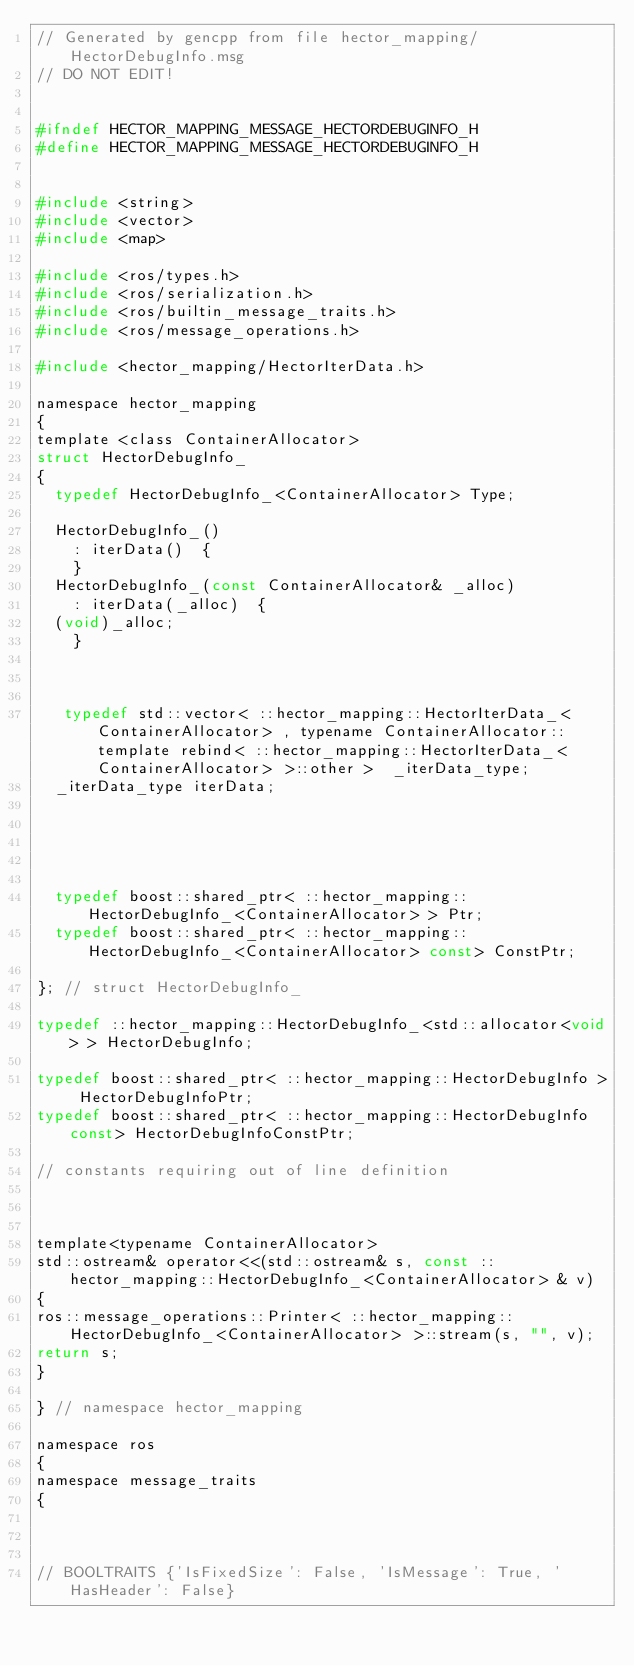<code> <loc_0><loc_0><loc_500><loc_500><_C_>// Generated by gencpp from file hector_mapping/HectorDebugInfo.msg
// DO NOT EDIT!


#ifndef HECTOR_MAPPING_MESSAGE_HECTORDEBUGINFO_H
#define HECTOR_MAPPING_MESSAGE_HECTORDEBUGINFO_H


#include <string>
#include <vector>
#include <map>

#include <ros/types.h>
#include <ros/serialization.h>
#include <ros/builtin_message_traits.h>
#include <ros/message_operations.h>

#include <hector_mapping/HectorIterData.h>

namespace hector_mapping
{
template <class ContainerAllocator>
struct HectorDebugInfo_
{
  typedef HectorDebugInfo_<ContainerAllocator> Type;

  HectorDebugInfo_()
    : iterData()  {
    }
  HectorDebugInfo_(const ContainerAllocator& _alloc)
    : iterData(_alloc)  {
  (void)_alloc;
    }



   typedef std::vector< ::hector_mapping::HectorIterData_<ContainerAllocator> , typename ContainerAllocator::template rebind< ::hector_mapping::HectorIterData_<ContainerAllocator> >::other >  _iterData_type;
  _iterData_type iterData;





  typedef boost::shared_ptr< ::hector_mapping::HectorDebugInfo_<ContainerAllocator> > Ptr;
  typedef boost::shared_ptr< ::hector_mapping::HectorDebugInfo_<ContainerAllocator> const> ConstPtr;

}; // struct HectorDebugInfo_

typedef ::hector_mapping::HectorDebugInfo_<std::allocator<void> > HectorDebugInfo;

typedef boost::shared_ptr< ::hector_mapping::HectorDebugInfo > HectorDebugInfoPtr;
typedef boost::shared_ptr< ::hector_mapping::HectorDebugInfo const> HectorDebugInfoConstPtr;

// constants requiring out of line definition



template<typename ContainerAllocator>
std::ostream& operator<<(std::ostream& s, const ::hector_mapping::HectorDebugInfo_<ContainerAllocator> & v)
{
ros::message_operations::Printer< ::hector_mapping::HectorDebugInfo_<ContainerAllocator> >::stream(s, "", v);
return s;
}

} // namespace hector_mapping

namespace ros
{
namespace message_traits
{



// BOOLTRAITS {'IsFixedSize': False, 'IsMessage': True, 'HasHeader': False}</code> 